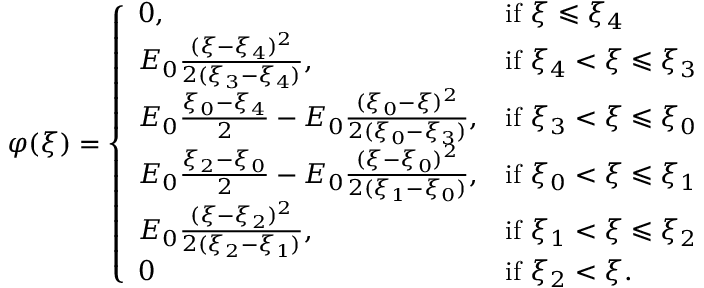Convert formula to latex. <formula><loc_0><loc_0><loc_500><loc_500>\begin{array} { r } { \varphi ( \xi ) = \left \{ \begin{array} { l l } { 0 , } & { i f \xi \leqslant \xi _ { 4 } } \\ { E _ { 0 } \frac { ( \xi - \xi _ { 4 } ) ^ { 2 } } { 2 ( \xi _ { 3 } - \xi _ { 4 } ) } , } & { i f \xi _ { 4 } < \xi \leqslant \xi _ { 3 } } \\ { E _ { 0 } \frac { \xi _ { 0 } - \xi _ { 4 } } { 2 } - E _ { 0 } \frac { ( \xi _ { 0 } - \xi ) ^ { 2 } } { 2 ( \xi _ { 0 } - \xi _ { 3 } ) } , } & { i f \xi _ { 3 } < \xi \leqslant \xi _ { 0 } } \\ { E _ { 0 } \frac { \xi _ { 2 } - \xi _ { 0 } } { 2 } - E _ { 0 } \frac { ( \xi - \xi _ { 0 } ) ^ { 2 } } { 2 ( \xi _ { 1 } - \xi _ { 0 } ) } , } & { i f \xi _ { 0 } < \xi \leqslant \xi _ { 1 } } \\ { E _ { 0 } \frac { ( \xi - \xi _ { 2 } ) ^ { 2 } } { 2 ( \xi _ { 2 } - \xi _ { 1 } ) } , } & { i f \xi _ { 1 } < \xi \leqslant \xi _ { 2 } } \\ { 0 } & { i f \xi _ { 2 } < \xi . } \end{array} } \end{array}</formula> 